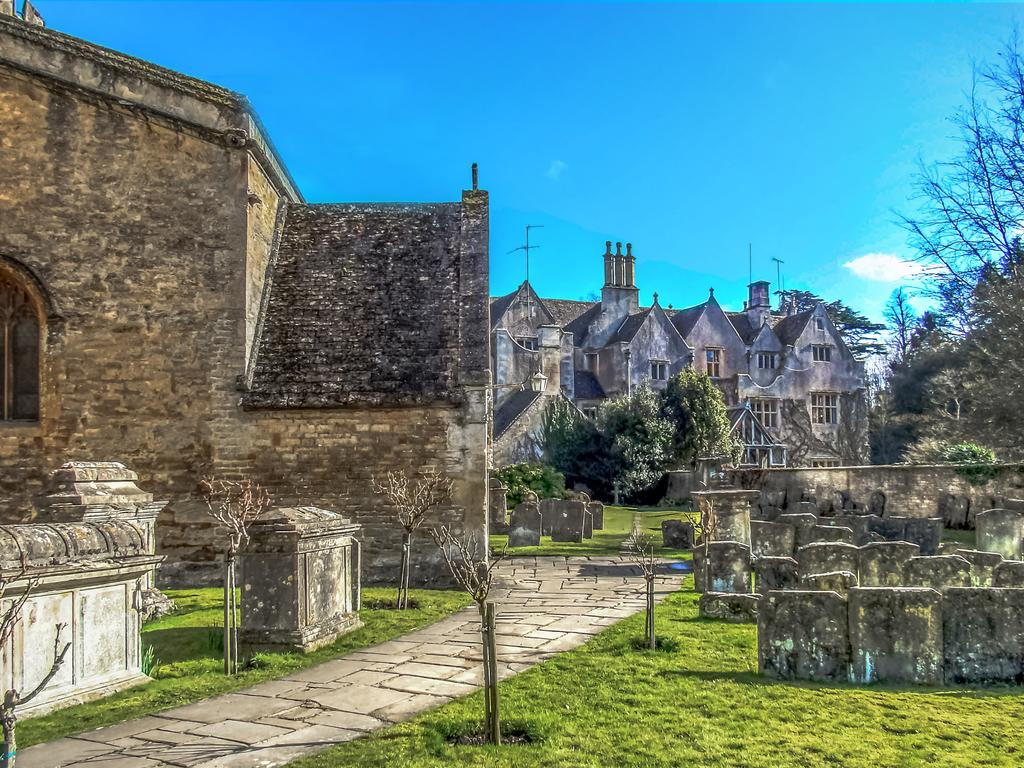What type of structures can be seen in the image? There are houses and buildings in the image. What type of vegetation is present in the image? There are plants and trees in the image. What type of ground cover is visible in the image? There is grass on the floor in the image. Can you see a baby making a wish on a landmark in the image? There is no baby or landmark present in the image. 